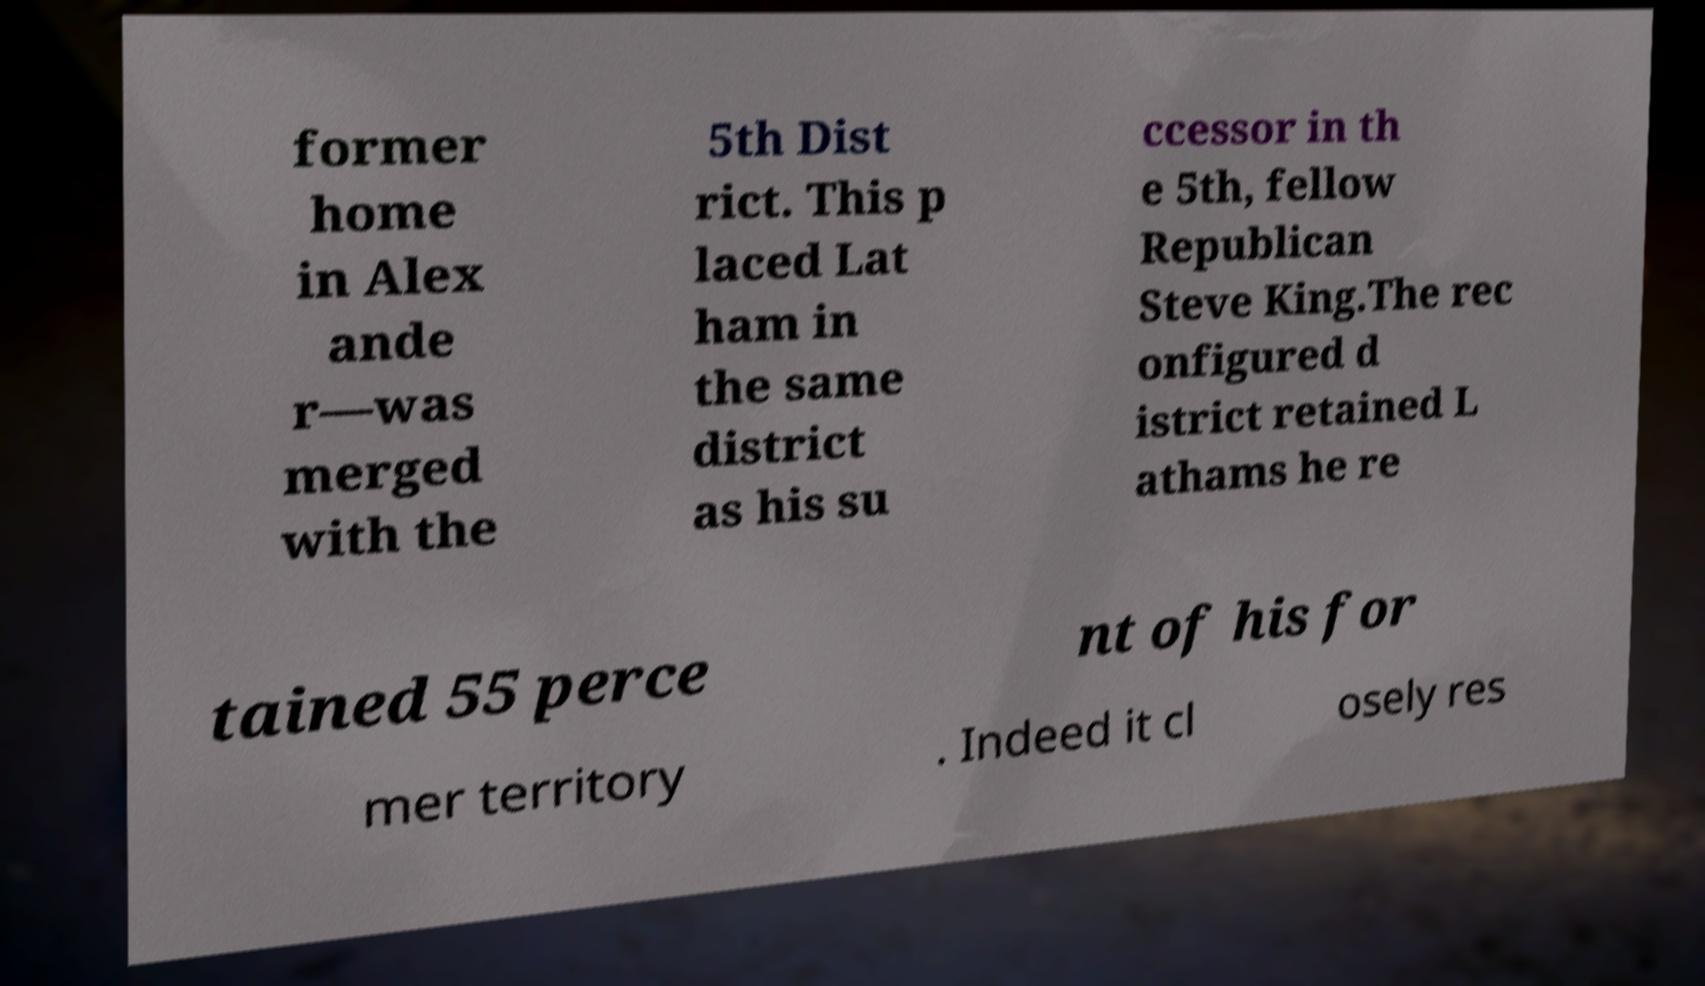Could you extract and type out the text from this image? former home in Alex ande r—was merged with the 5th Dist rict. This p laced Lat ham in the same district as his su ccessor in th e 5th, fellow Republican Steve King.The rec onfigured d istrict retained L athams he re tained 55 perce nt of his for mer territory . Indeed it cl osely res 